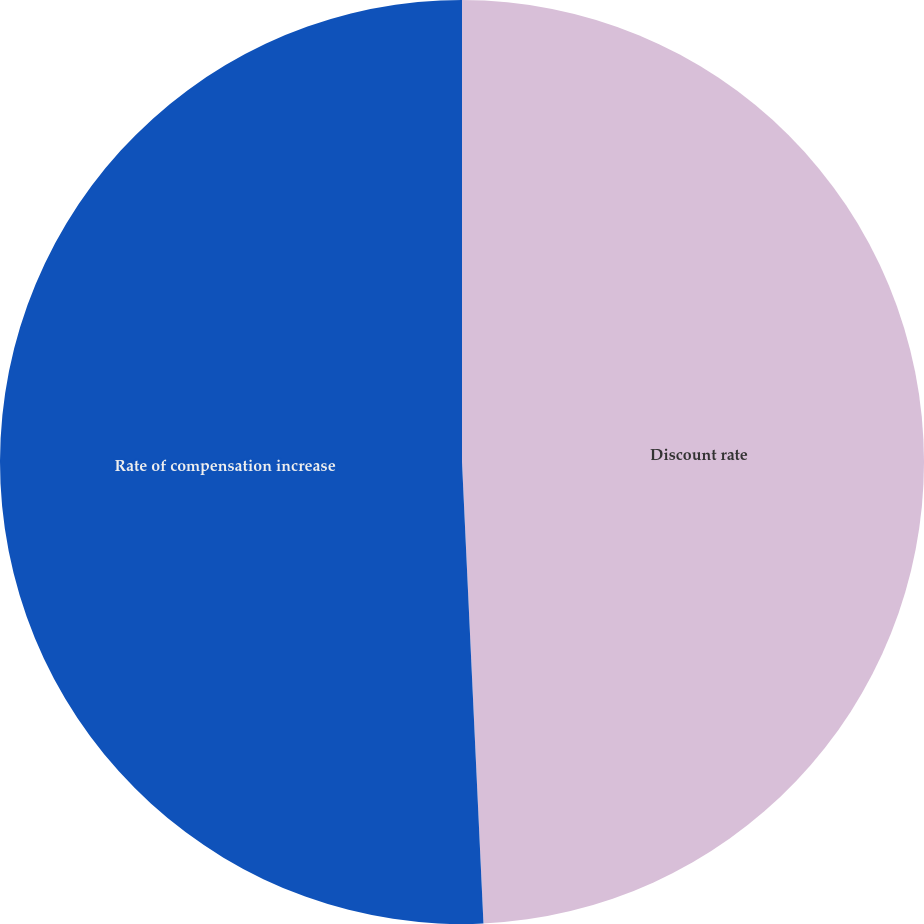<chart> <loc_0><loc_0><loc_500><loc_500><pie_chart><fcel>Discount rate<fcel>Rate of compensation increase<nl><fcel>49.26%<fcel>50.74%<nl></chart> 